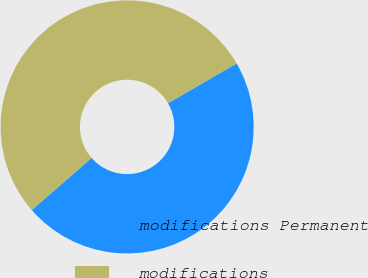Convert chart. <chart><loc_0><loc_0><loc_500><loc_500><pie_chart><fcel>modifications Permanent<fcel>modifications<nl><fcel>46.94%<fcel>53.06%<nl></chart> 